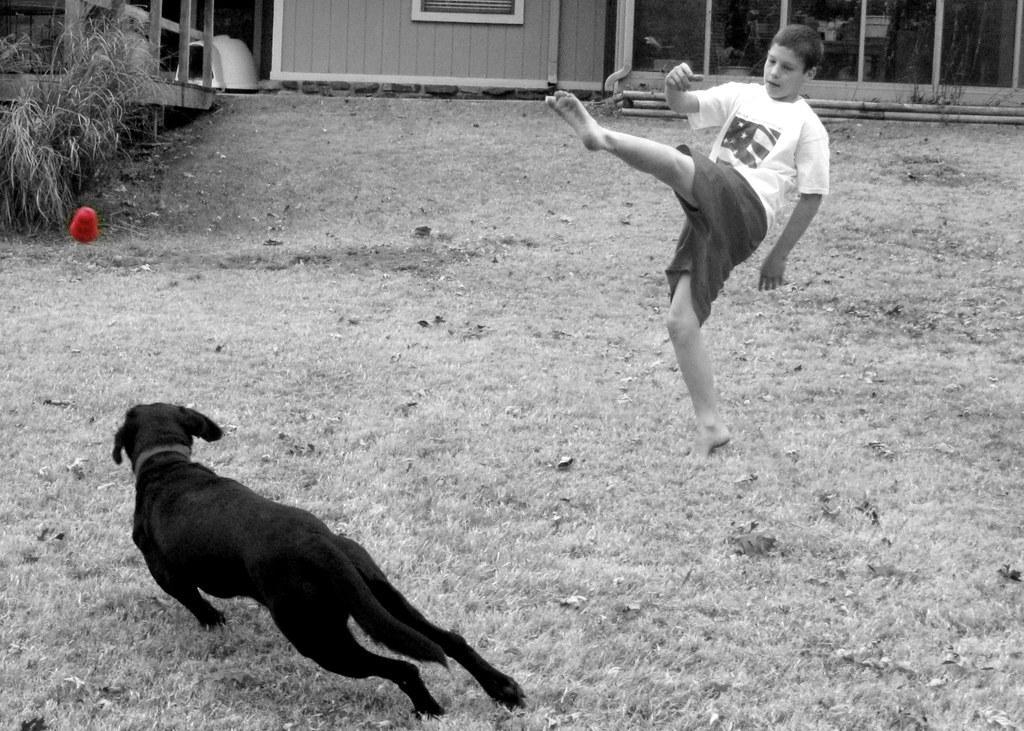In one or two sentences, can you explain what this image depicts? In the picture we can see a mud surface on it, we can see a boy standing on one leg and he is wearing a white T-shirt and front of him we can see a dog running which is black in color and in the background we can see some grass plants and a wall. 